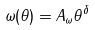<formula> <loc_0><loc_0><loc_500><loc_500>\omega ( \theta ) = A _ { \omega } \theta ^ { \delta }</formula> 